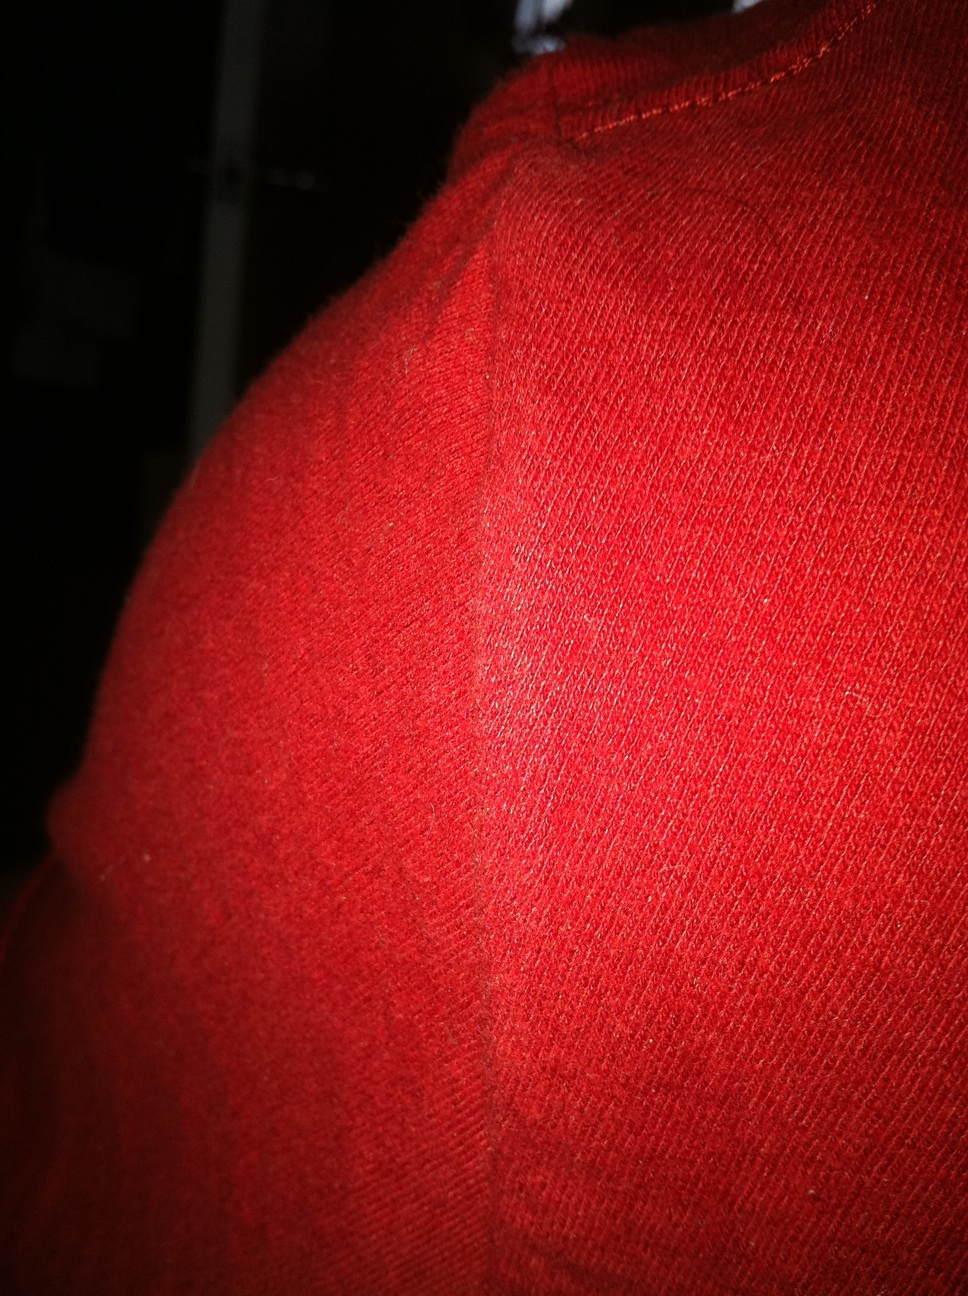What types of occasions would you recommend wearing apparel made from this fabric? Apparel made from this vibrant red, ribbed fabric is versatile and can be worn for a variety of occasions. This includes casual outings, such as a cozy day at the coffee shop or while shopping. Its eye-catching color also makes it suitable for more festive events like holiday parties, adding a touch of warmth and cheer to the celebration. Can you describe a stylish winter outfit incorporating this fabric? Certainly! Imagine a cozy winter outfit centered around a rich, red knitted sweater made from this fabric. Pair it with a sleek black pea coat and stylish dark jeans for a balanced and sophisticated look. Add a matching beanie and scarf in the sharegpt4v/same vibrant red fabric to keep warm. Finish the look with black leather boots and a pair of gloves. This outfit not only ensures warmth but also makes a bold fashion statement. 